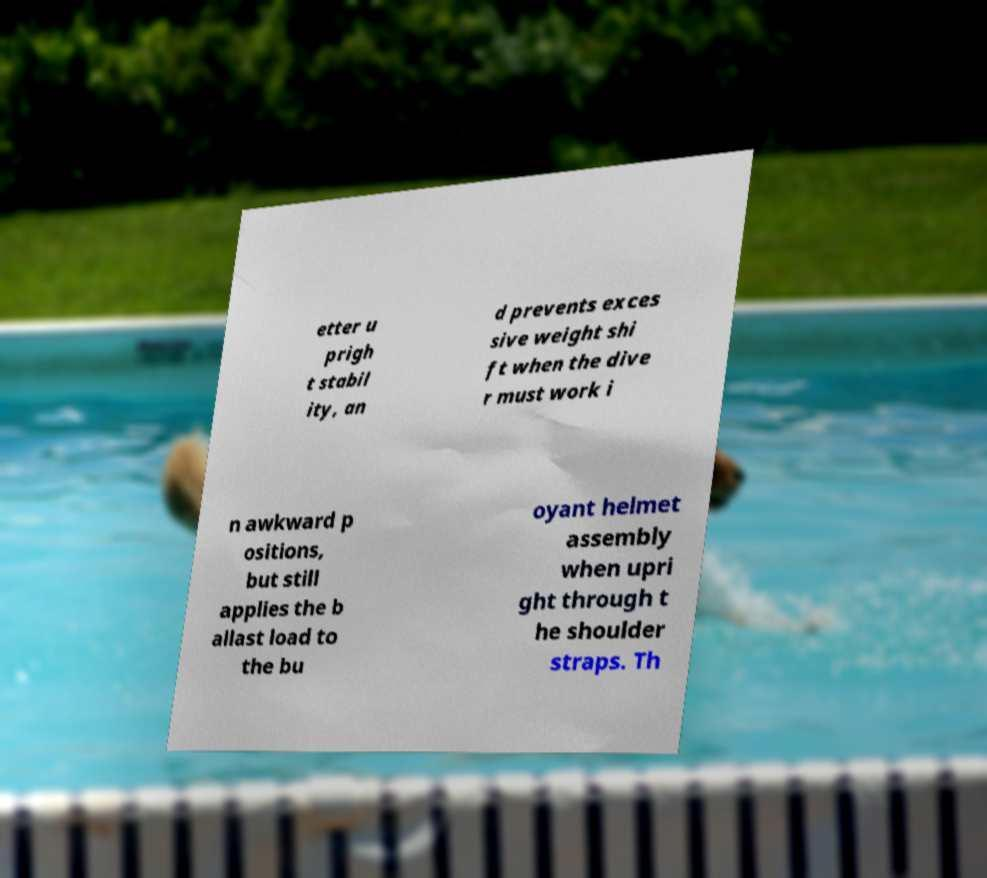What messages or text are displayed in this image? I need them in a readable, typed format. etter u prigh t stabil ity, an d prevents exces sive weight shi ft when the dive r must work i n awkward p ositions, but still applies the b allast load to the bu oyant helmet assembly when upri ght through t he shoulder straps. Th 